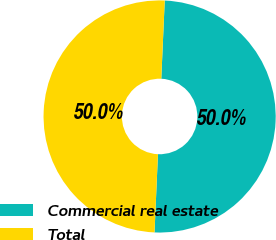<chart> <loc_0><loc_0><loc_500><loc_500><pie_chart><fcel>Commercial real estate<fcel>Total<nl><fcel>50.0%<fcel>50.0%<nl></chart> 